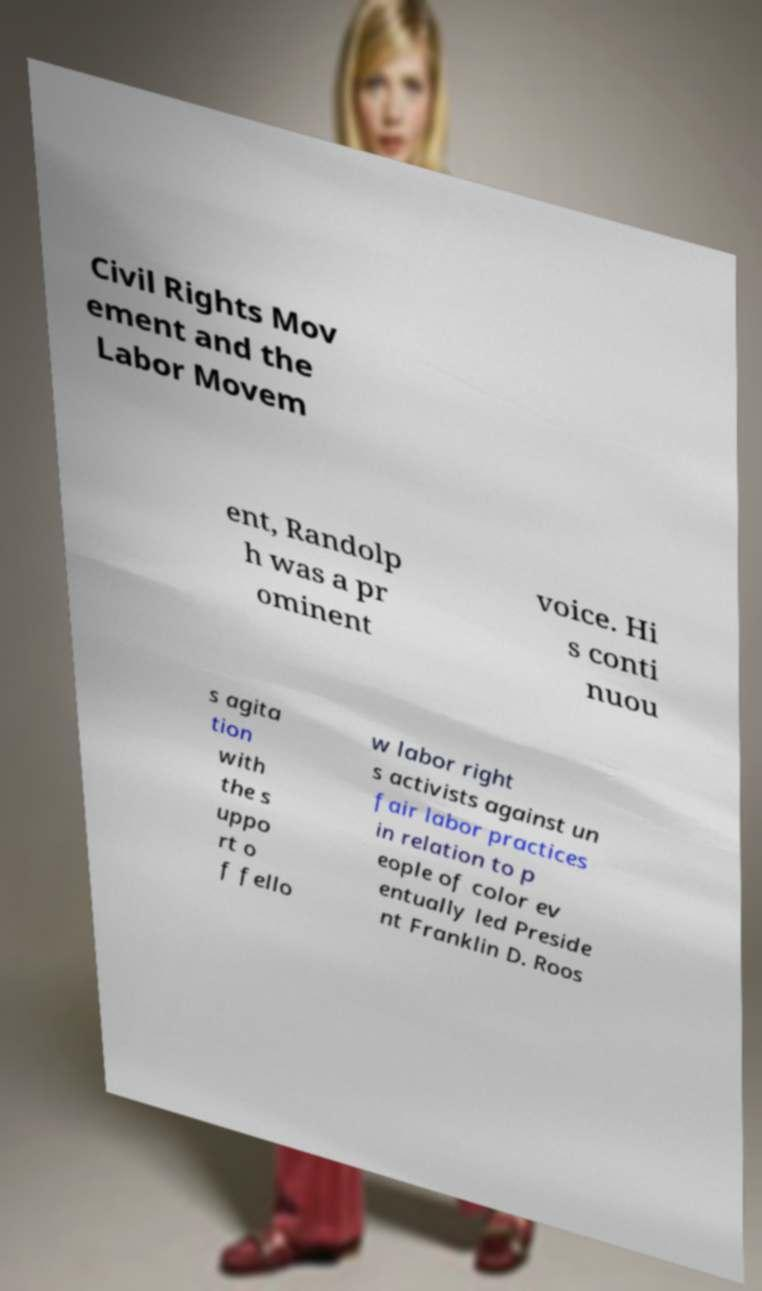Please read and relay the text visible in this image. What does it say? Civil Rights Mov ement and the Labor Movem ent, Randolp h was a pr ominent voice. Hi s conti nuou s agita tion with the s uppo rt o f fello w labor right s activists against un fair labor practices in relation to p eople of color ev entually led Preside nt Franklin D. Roos 